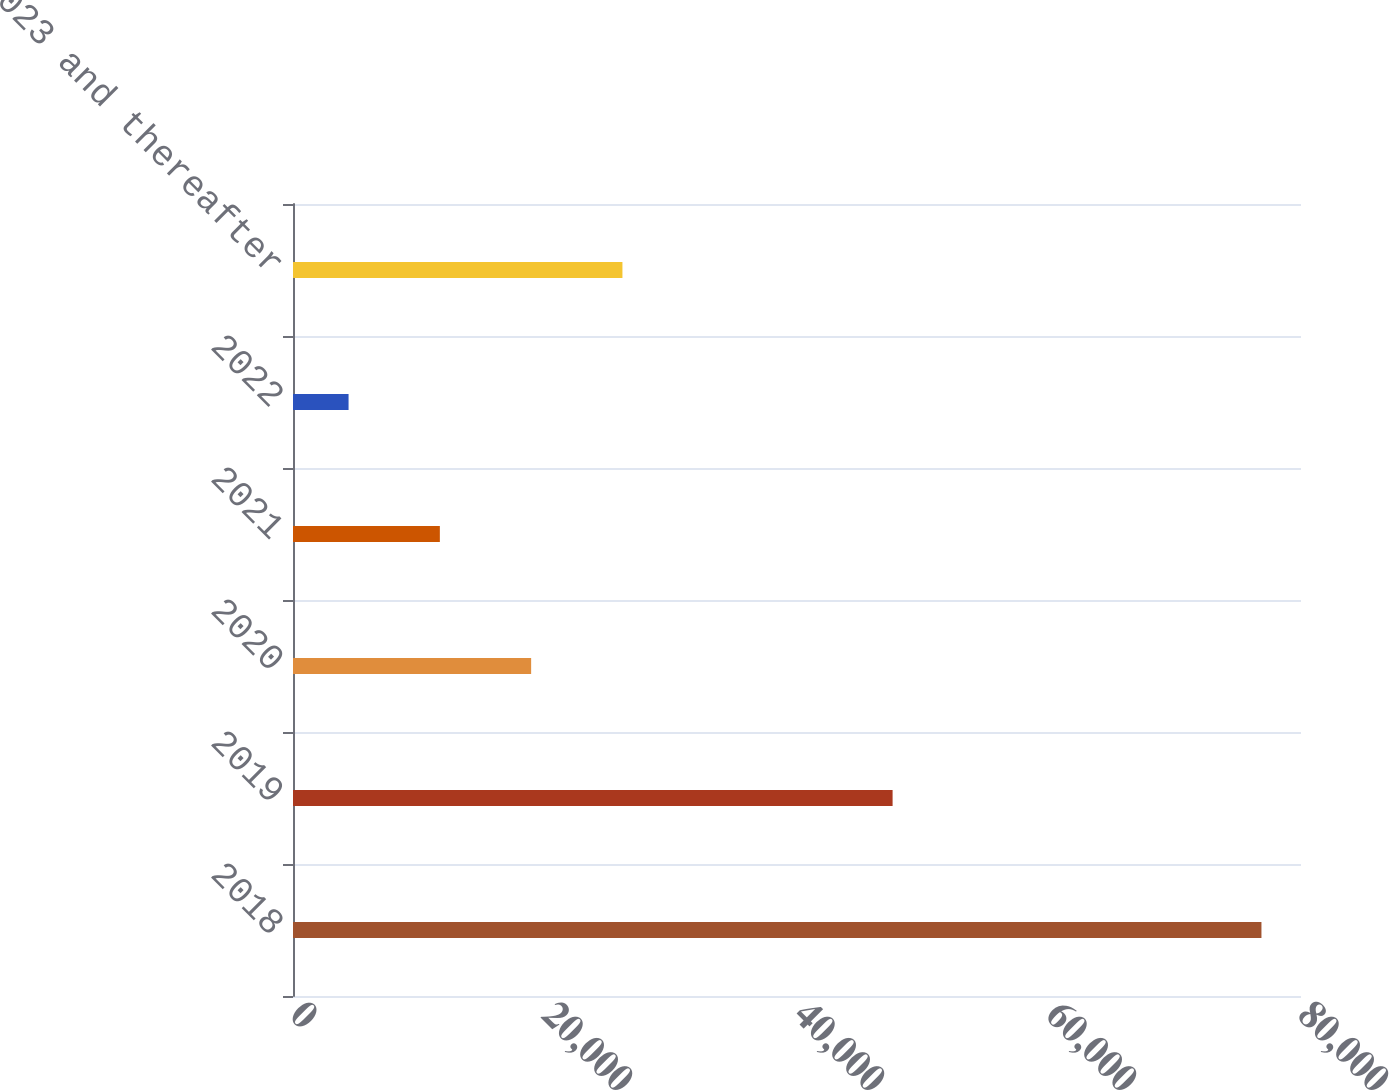Convert chart. <chart><loc_0><loc_0><loc_500><loc_500><bar_chart><fcel>2018<fcel>2019<fcel>2020<fcel>2021<fcel>2022<fcel>2023 and thereafter<nl><fcel>76861<fcel>47587<fcel>18900.2<fcel>11655.1<fcel>4410<fcel>26145.3<nl></chart> 